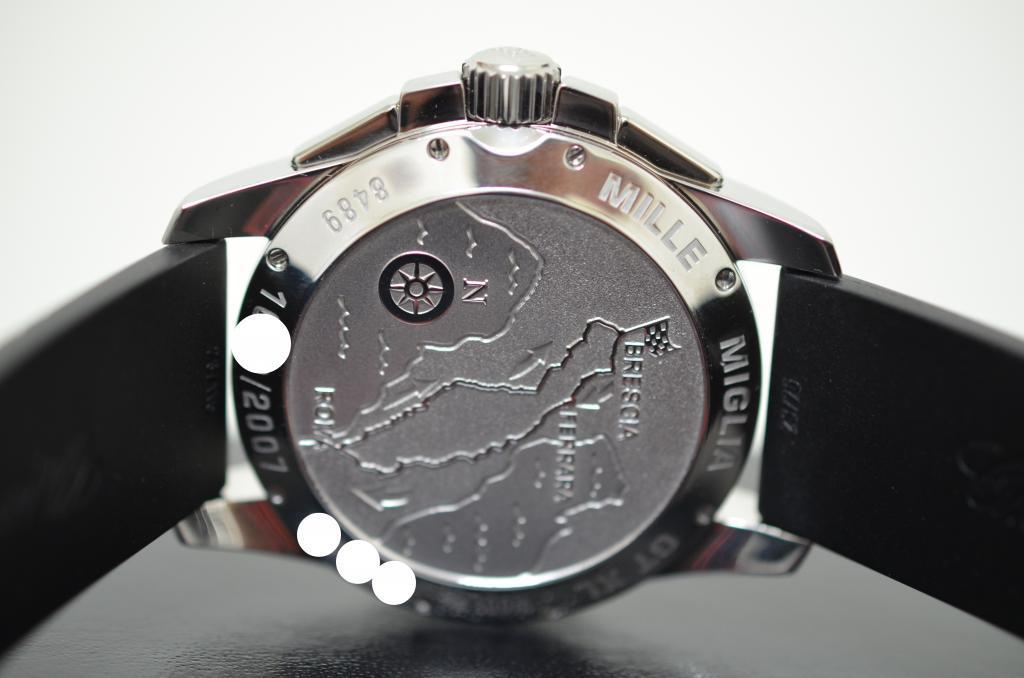<image>
Provide a brief description of the given image. The back of a watch with a map on it and it says Miglia at the top. 